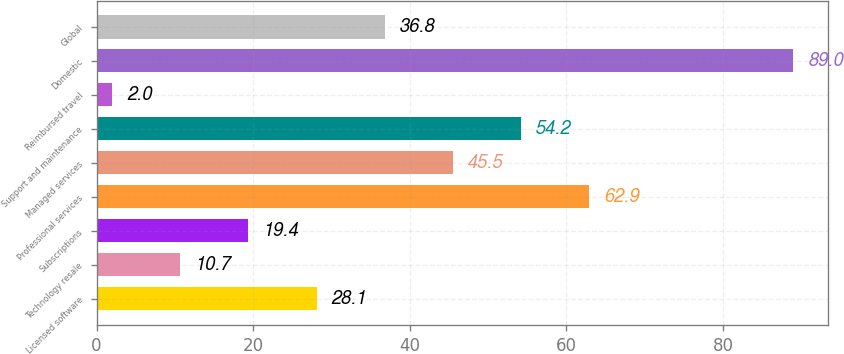Convert chart. <chart><loc_0><loc_0><loc_500><loc_500><bar_chart><fcel>Licensed software<fcel>Technology resale<fcel>Subscriptions<fcel>Professional services<fcel>Managed services<fcel>Support and maintenance<fcel>Reimbursed travel<fcel>Domestic<fcel>Global<nl><fcel>28.1<fcel>10.7<fcel>19.4<fcel>62.9<fcel>45.5<fcel>54.2<fcel>2<fcel>89<fcel>36.8<nl></chart> 